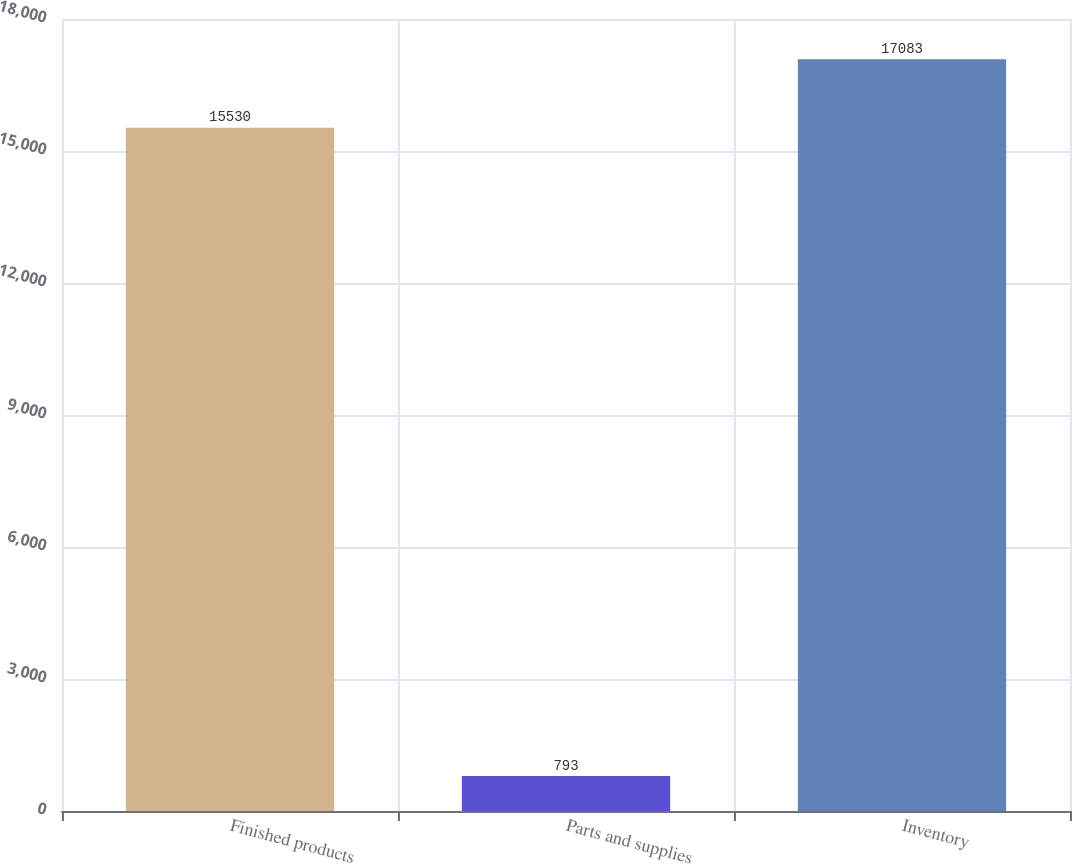Convert chart. <chart><loc_0><loc_0><loc_500><loc_500><bar_chart><fcel>Finished products<fcel>Parts and supplies<fcel>Inventory<nl><fcel>15530<fcel>793<fcel>17083<nl></chart> 